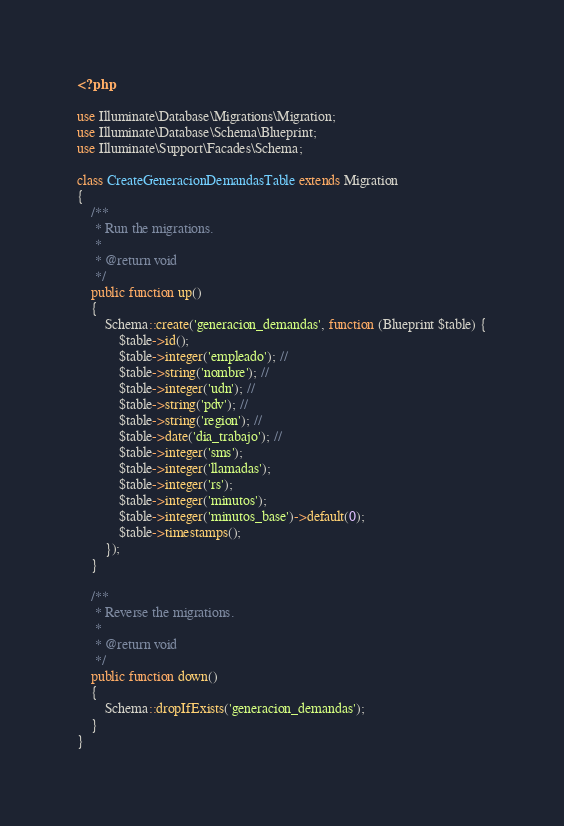<code> <loc_0><loc_0><loc_500><loc_500><_PHP_><?php

use Illuminate\Database\Migrations\Migration;
use Illuminate\Database\Schema\Blueprint;
use Illuminate\Support\Facades\Schema;

class CreateGeneracionDemandasTable extends Migration
{
    /**
     * Run the migrations.
     *
     * @return void
     */
    public function up()
    {
        Schema::create('generacion_demandas', function (Blueprint $table) {
            $table->id();
            $table->integer('empleado'); //
            $table->string('nombre'); //
            $table->integer('udn'); //
            $table->string('pdv'); //
            $table->string('region'); //
            $table->date('dia_trabajo'); //
            $table->integer('sms');
            $table->integer('llamadas');
            $table->integer('rs');
            $table->integer('minutos');
            $table->integer('minutos_base')->default(0);
            $table->timestamps();
        });
    }

    /**
     * Reverse the migrations.
     *
     * @return void
     */
    public function down()
    {
        Schema::dropIfExists('generacion_demandas');
    }
}
</code> 